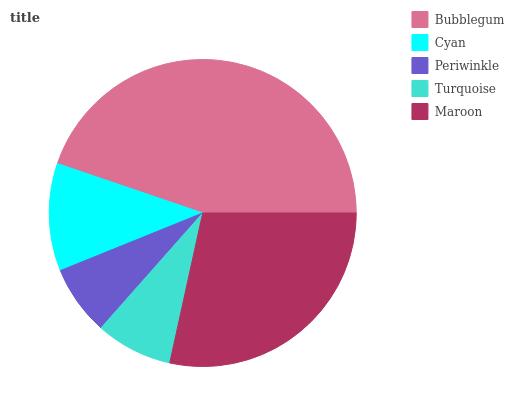Is Periwinkle the minimum?
Answer yes or no. Yes. Is Bubblegum the maximum?
Answer yes or no. Yes. Is Cyan the minimum?
Answer yes or no. No. Is Cyan the maximum?
Answer yes or no. No. Is Bubblegum greater than Cyan?
Answer yes or no. Yes. Is Cyan less than Bubblegum?
Answer yes or no. Yes. Is Cyan greater than Bubblegum?
Answer yes or no. No. Is Bubblegum less than Cyan?
Answer yes or no. No. Is Cyan the high median?
Answer yes or no. Yes. Is Cyan the low median?
Answer yes or no. Yes. Is Turquoise the high median?
Answer yes or no. No. Is Turquoise the low median?
Answer yes or no. No. 